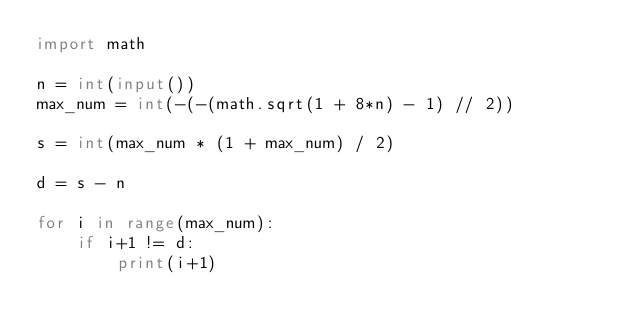Convert code to text. <code><loc_0><loc_0><loc_500><loc_500><_Python_>import math

n = int(input())
max_num = int(-(-(math.sqrt(1 + 8*n) - 1) // 2))

s = int(max_num * (1 + max_num) / 2)

d = s - n

for i in range(max_num):
    if i+1 != d:
        print(i+1)</code> 